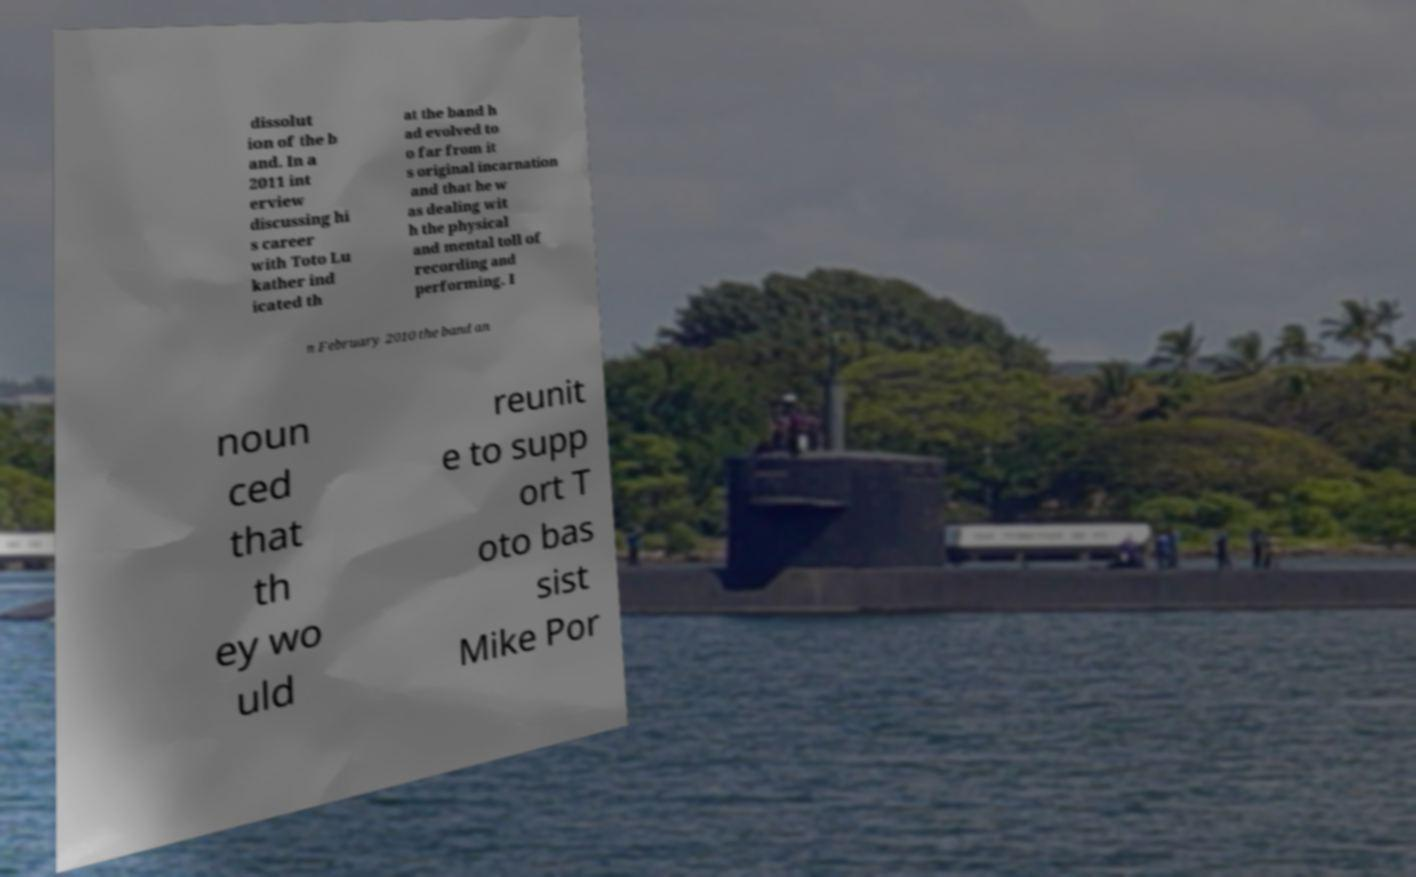I need the written content from this picture converted into text. Can you do that? dissolut ion of the b and. In a 2011 int erview discussing hi s career with Toto Lu kather ind icated th at the band h ad evolved to o far from it s original incarnation and that he w as dealing wit h the physical and mental toll of recording and performing. I n February 2010 the band an noun ced that th ey wo uld reunit e to supp ort T oto bas sist Mike Por 